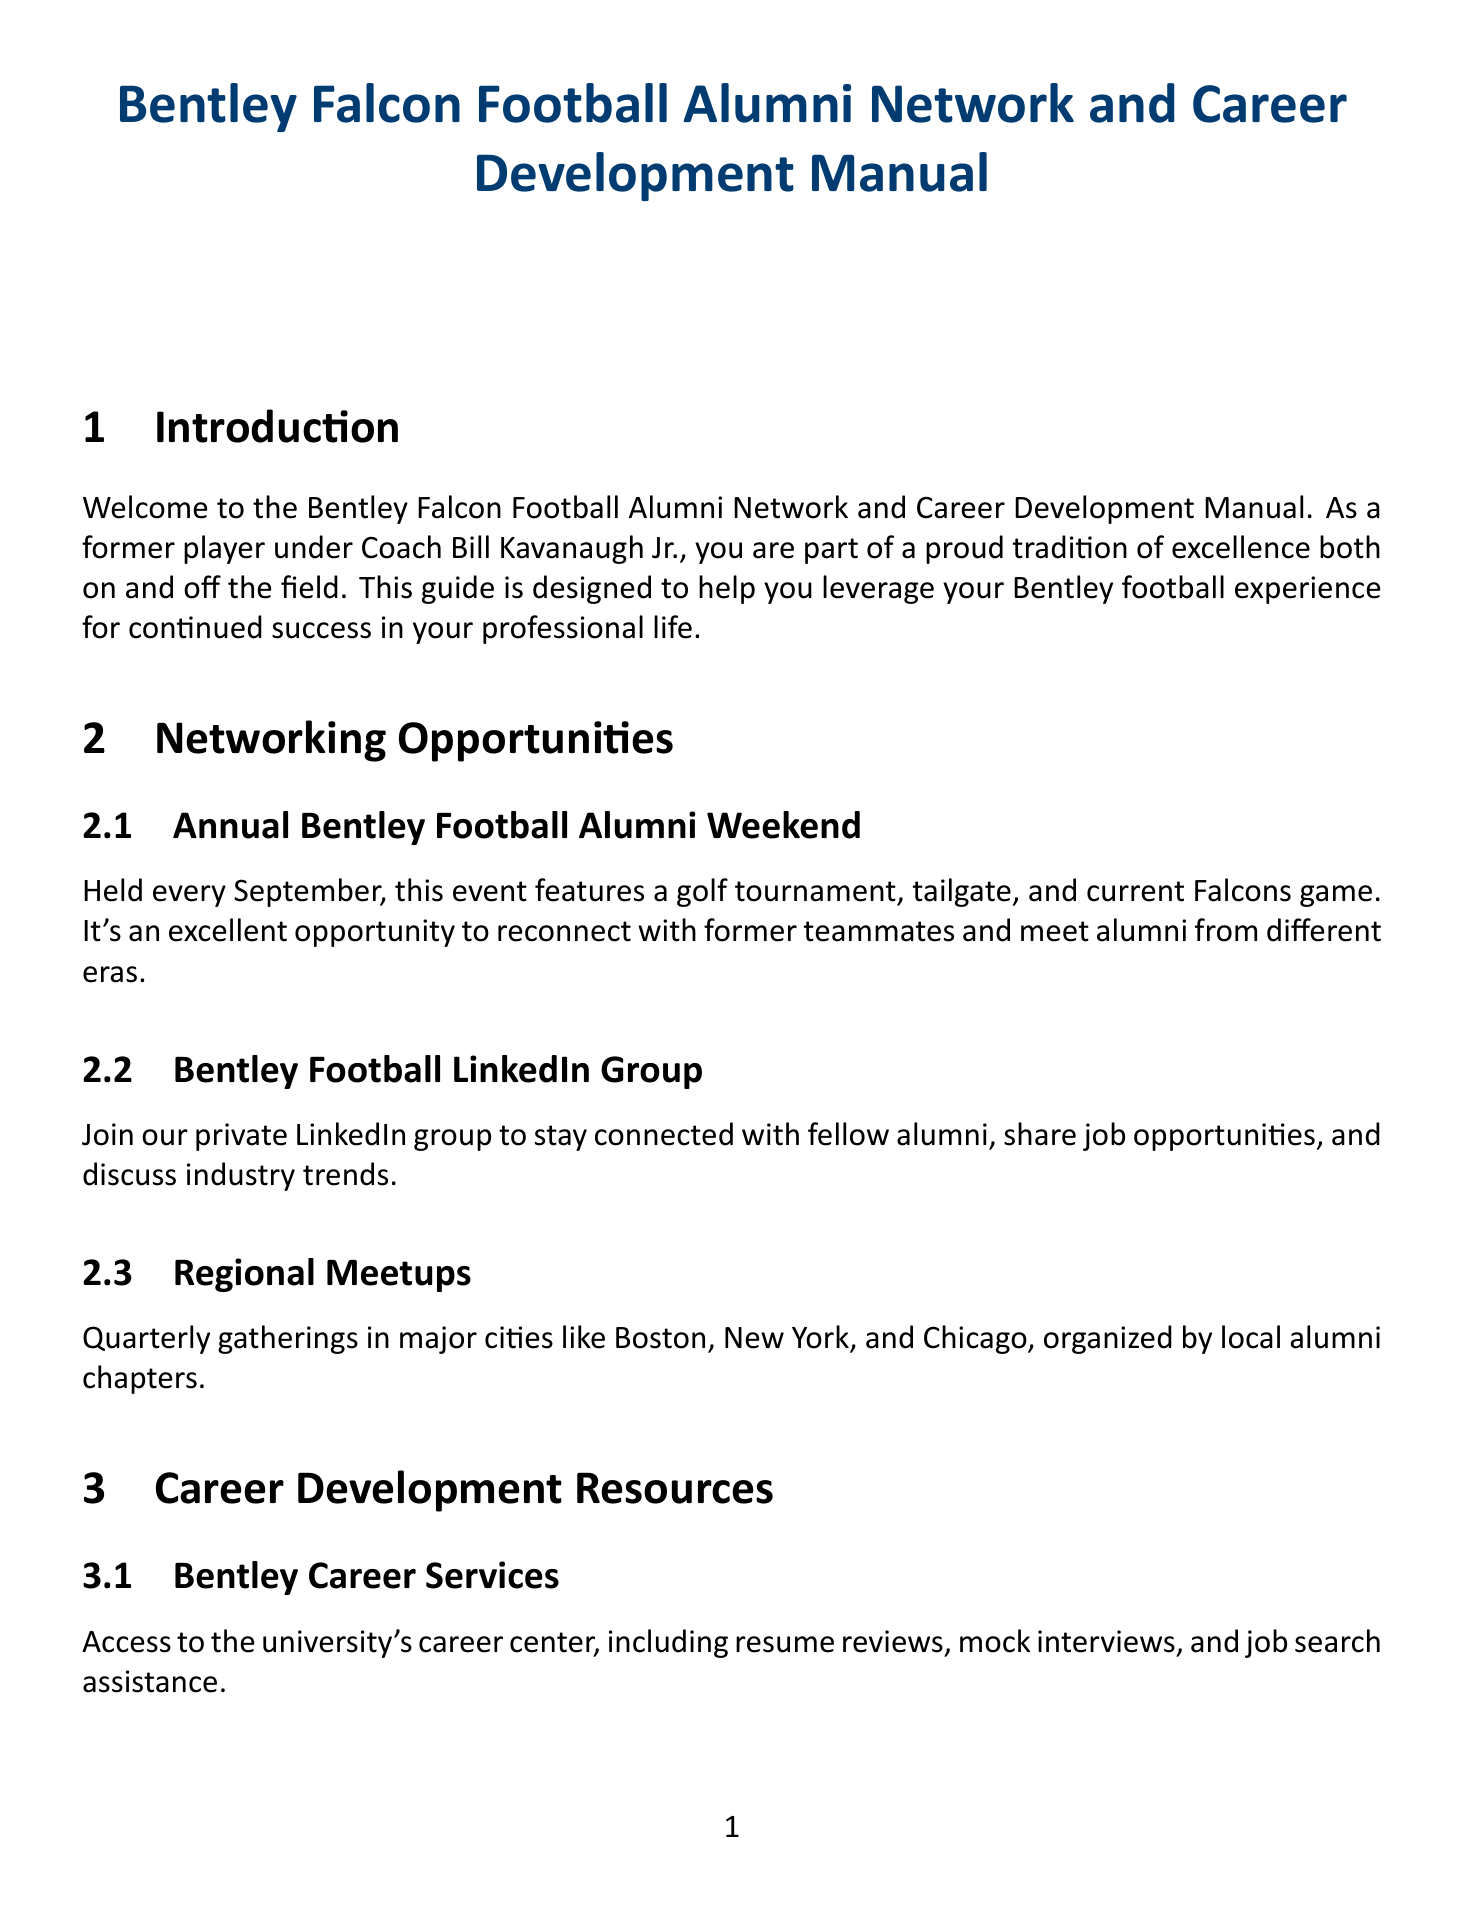What is the title of the manual? The title of the manual is stated at the beginning of the document.
Answer: Bentley Falcon Football Alumni Network and Career Development Manual When is the Annual Bentley Football Alumni Weekend held? The document specifies the timing of this event in September.
Answer: September Who is quoted as stating the importance of discipline learned as a Falcon? This information can be found in the Alumni Spotlight section where success stories are shared.
Answer: Mike Mahoney '08 What type of program connects alumni with successful Bentley football alumni? This program is designed for alumni to seek guidance from experienced peers in their industry.
Answer: Alumni Mentorship Program Which cities host Regional Meetups? The document lists major cities where these gatherings occur.
Answer: Boston, New York, Chicago What is one major resource provided by Bentley Career Services? The document mentions specific services included in career support offered to alumni.
Answer: Resume reviews What educational opportunity offers potential scholarships for football alumni? The document describes specific programs targeted at alumni success including scholarships.
Answer: Bentley MBA Program What does the Falcon Mentorship Program involve? The document outlines the purpose of this program regarding current players.
Answer: Guide current Bentley football players How frequently do Industry-Specific Webinars occur? The timing of these webinars is explained in the Career Development Resources section.
Answer: Monthly 